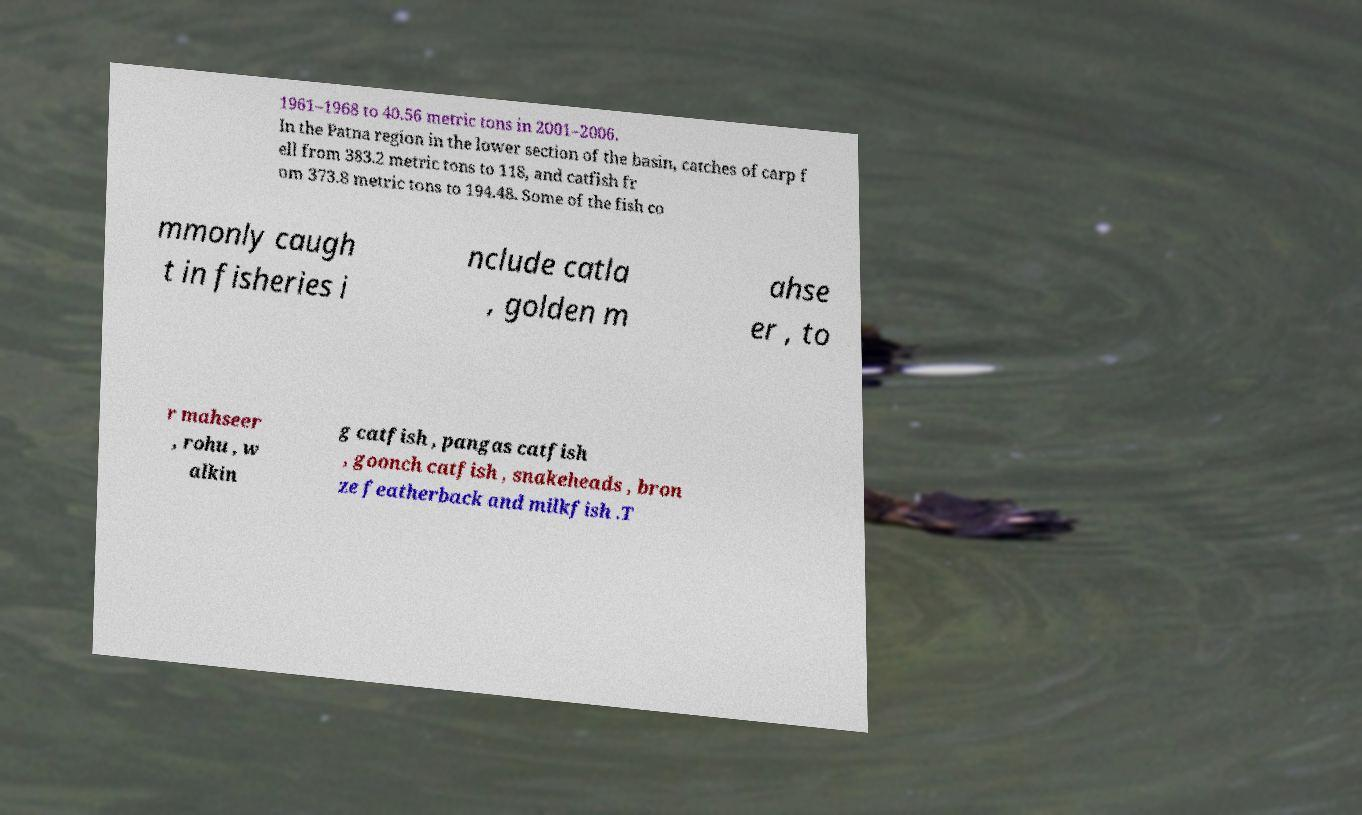There's text embedded in this image that I need extracted. Can you transcribe it verbatim? 1961–1968 to 40.56 metric tons in 2001–2006. In the Patna region in the lower section of the basin, catches of carp f ell from 383.2 metric tons to 118, and catfish fr om 373.8 metric tons to 194.48. Some of the fish co mmonly caugh t in fisheries i nclude catla , golden m ahse er , to r mahseer , rohu , w alkin g catfish , pangas catfish , goonch catfish , snakeheads , bron ze featherback and milkfish .T 